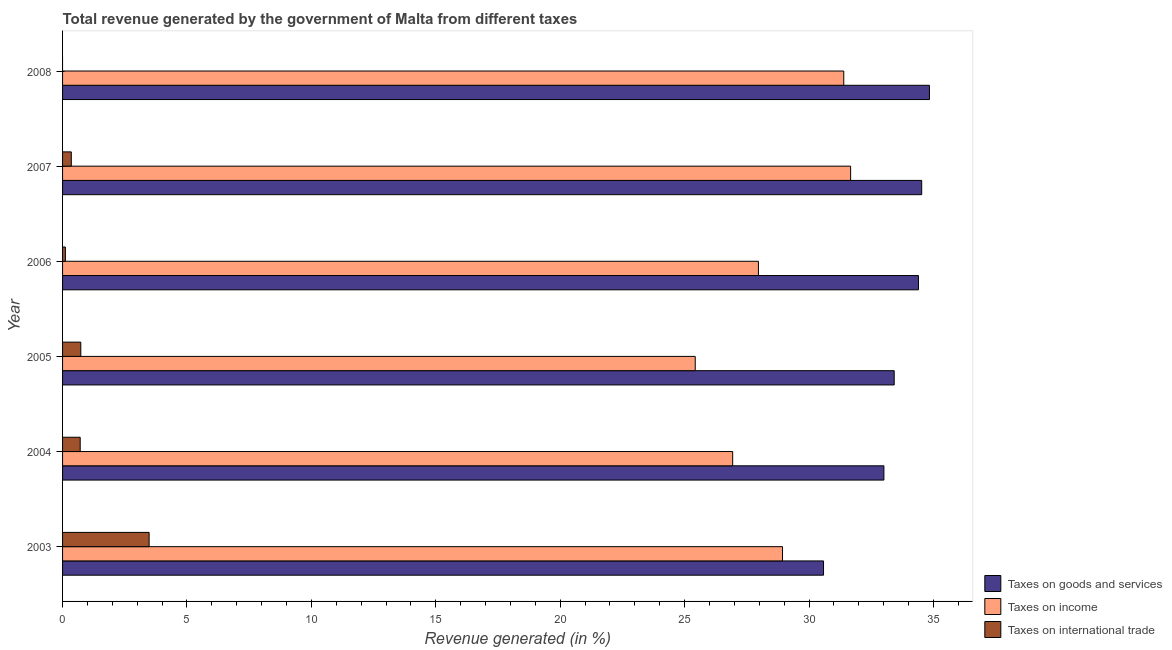Are the number of bars on each tick of the Y-axis equal?
Your answer should be very brief. No. What is the label of the 3rd group of bars from the top?
Give a very brief answer. 2006. In how many cases, is the number of bars for a given year not equal to the number of legend labels?
Keep it short and to the point. 1. What is the percentage of revenue generated by tax on international trade in 2004?
Make the answer very short. 0.71. Across all years, what is the maximum percentage of revenue generated by taxes on goods and services?
Your answer should be compact. 34.84. Across all years, what is the minimum percentage of revenue generated by taxes on income?
Your answer should be compact. 25.43. In which year was the percentage of revenue generated by taxes on goods and services maximum?
Make the answer very short. 2008. What is the total percentage of revenue generated by tax on international trade in the graph?
Provide a succinct answer. 5.38. What is the difference between the percentage of revenue generated by taxes on goods and services in 2003 and that in 2004?
Make the answer very short. -2.43. What is the difference between the percentage of revenue generated by taxes on goods and services in 2008 and the percentage of revenue generated by taxes on income in 2005?
Your answer should be compact. 9.41. What is the average percentage of revenue generated by tax on international trade per year?
Ensure brevity in your answer.  0.9. In the year 2007, what is the difference between the percentage of revenue generated by taxes on income and percentage of revenue generated by taxes on goods and services?
Your answer should be compact. -2.86. What is the ratio of the percentage of revenue generated by tax on international trade in 2004 to that in 2007?
Offer a very short reply. 2.02. Is the percentage of revenue generated by taxes on goods and services in 2004 less than that in 2006?
Your answer should be very brief. Yes. Is the difference between the percentage of revenue generated by taxes on income in 2004 and 2005 greater than the difference between the percentage of revenue generated by tax on international trade in 2004 and 2005?
Ensure brevity in your answer.  Yes. What is the difference between the highest and the second highest percentage of revenue generated by taxes on income?
Keep it short and to the point. 0.28. What is the difference between the highest and the lowest percentage of revenue generated by taxes on goods and services?
Ensure brevity in your answer.  4.26. In how many years, is the percentage of revenue generated by tax on international trade greater than the average percentage of revenue generated by tax on international trade taken over all years?
Your answer should be very brief. 1. Is the sum of the percentage of revenue generated by taxes on income in 2004 and 2006 greater than the maximum percentage of revenue generated by taxes on goods and services across all years?
Give a very brief answer. Yes. How many bars are there?
Your answer should be very brief. 17. Are all the bars in the graph horizontal?
Ensure brevity in your answer.  Yes. How many years are there in the graph?
Your answer should be compact. 6. What is the difference between two consecutive major ticks on the X-axis?
Ensure brevity in your answer.  5. Does the graph contain grids?
Your answer should be very brief. No. Where does the legend appear in the graph?
Offer a very short reply. Bottom right. How many legend labels are there?
Your answer should be very brief. 3. How are the legend labels stacked?
Offer a very short reply. Vertical. What is the title of the graph?
Provide a succinct answer. Total revenue generated by the government of Malta from different taxes. What is the label or title of the X-axis?
Offer a terse response. Revenue generated (in %). What is the Revenue generated (in %) of Taxes on goods and services in 2003?
Your answer should be very brief. 30.58. What is the Revenue generated (in %) in Taxes on income in 2003?
Provide a succinct answer. 28.93. What is the Revenue generated (in %) in Taxes on international trade in 2003?
Keep it short and to the point. 3.48. What is the Revenue generated (in %) in Taxes on goods and services in 2004?
Make the answer very short. 33.01. What is the Revenue generated (in %) in Taxes on income in 2004?
Make the answer very short. 26.93. What is the Revenue generated (in %) in Taxes on international trade in 2004?
Provide a succinct answer. 0.71. What is the Revenue generated (in %) of Taxes on goods and services in 2005?
Your answer should be very brief. 33.42. What is the Revenue generated (in %) in Taxes on income in 2005?
Your answer should be very brief. 25.43. What is the Revenue generated (in %) of Taxes on international trade in 2005?
Provide a short and direct response. 0.73. What is the Revenue generated (in %) of Taxes on goods and services in 2006?
Make the answer very short. 34.4. What is the Revenue generated (in %) of Taxes on income in 2006?
Keep it short and to the point. 27.97. What is the Revenue generated (in %) of Taxes on international trade in 2006?
Offer a very short reply. 0.11. What is the Revenue generated (in %) of Taxes on goods and services in 2007?
Provide a short and direct response. 34.53. What is the Revenue generated (in %) in Taxes on income in 2007?
Your answer should be compact. 31.67. What is the Revenue generated (in %) of Taxes on international trade in 2007?
Keep it short and to the point. 0.35. What is the Revenue generated (in %) in Taxes on goods and services in 2008?
Ensure brevity in your answer.  34.84. What is the Revenue generated (in %) of Taxes on income in 2008?
Your answer should be compact. 31.4. What is the Revenue generated (in %) of Taxes on international trade in 2008?
Give a very brief answer. 0. Across all years, what is the maximum Revenue generated (in %) of Taxes on goods and services?
Your answer should be very brief. 34.84. Across all years, what is the maximum Revenue generated (in %) in Taxes on income?
Ensure brevity in your answer.  31.67. Across all years, what is the maximum Revenue generated (in %) in Taxes on international trade?
Offer a very short reply. 3.48. Across all years, what is the minimum Revenue generated (in %) of Taxes on goods and services?
Make the answer very short. 30.58. Across all years, what is the minimum Revenue generated (in %) in Taxes on income?
Provide a succinct answer. 25.43. What is the total Revenue generated (in %) of Taxes on goods and services in the graph?
Keep it short and to the point. 200.78. What is the total Revenue generated (in %) in Taxes on income in the graph?
Provide a succinct answer. 172.32. What is the total Revenue generated (in %) in Taxes on international trade in the graph?
Offer a very short reply. 5.38. What is the difference between the Revenue generated (in %) in Taxes on goods and services in 2003 and that in 2004?
Provide a succinct answer. -2.43. What is the difference between the Revenue generated (in %) in Taxes on income in 2003 and that in 2004?
Keep it short and to the point. 2. What is the difference between the Revenue generated (in %) in Taxes on international trade in 2003 and that in 2004?
Provide a short and direct response. 2.77. What is the difference between the Revenue generated (in %) of Taxes on goods and services in 2003 and that in 2005?
Provide a succinct answer. -2.84. What is the difference between the Revenue generated (in %) in Taxes on income in 2003 and that in 2005?
Provide a short and direct response. 3.51. What is the difference between the Revenue generated (in %) of Taxes on international trade in 2003 and that in 2005?
Offer a very short reply. 2.75. What is the difference between the Revenue generated (in %) of Taxes on goods and services in 2003 and that in 2006?
Your response must be concise. -3.81. What is the difference between the Revenue generated (in %) of Taxes on income in 2003 and that in 2006?
Make the answer very short. 0.97. What is the difference between the Revenue generated (in %) of Taxes on international trade in 2003 and that in 2006?
Provide a succinct answer. 3.37. What is the difference between the Revenue generated (in %) in Taxes on goods and services in 2003 and that in 2007?
Provide a succinct answer. -3.95. What is the difference between the Revenue generated (in %) in Taxes on income in 2003 and that in 2007?
Give a very brief answer. -2.74. What is the difference between the Revenue generated (in %) in Taxes on international trade in 2003 and that in 2007?
Your answer should be compact. 3.13. What is the difference between the Revenue generated (in %) in Taxes on goods and services in 2003 and that in 2008?
Ensure brevity in your answer.  -4.26. What is the difference between the Revenue generated (in %) of Taxes on income in 2003 and that in 2008?
Ensure brevity in your answer.  -2.46. What is the difference between the Revenue generated (in %) in Taxes on goods and services in 2004 and that in 2005?
Offer a terse response. -0.41. What is the difference between the Revenue generated (in %) in Taxes on income in 2004 and that in 2005?
Ensure brevity in your answer.  1.5. What is the difference between the Revenue generated (in %) of Taxes on international trade in 2004 and that in 2005?
Make the answer very short. -0.02. What is the difference between the Revenue generated (in %) in Taxes on goods and services in 2004 and that in 2006?
Give a very brief answer. -1.39. What is the difference between the Revenue generated (in %) in Taxes on income in 2004 and that in 2006?
Ensure brevity in your answer.  -1.03. What is the difference between the Revenue generated (in %) of Taxes on international trade in 2004 and that in 2006?
Provide a succinct answer. 0.59. What is the difference between the Revenue generated (in %) of Taxes on goods and services in 2004 and that in 2007?
Your answer should be very brief. -1.52. What is the difference between the Revenue generated (in %) of Taxes on income in 2004 and that in 2007?
Keep it short and to the point. -4.74. What is the difference between the Revenue generated (in %) of Taxes on international trade in 2004 and that in 2007?
Your answer should be very brief. 0.36. What is the difference between the Revenue generated (in %) in Taxes on goods and services in 2004 and that in 2008?
Your answer should be compact. -1.83. What is the difference between the Revenue generated (in %) in Taxes on income in 2004 and that in 2008?
Your response must be concise. -4.46. What is the difference between the Revenue generated (in %) in Taxes on goods and services in 2005 and that in 2006?
Provide a succinct answer. -0.97. What is the difference between the Revenue generated (in %) of Taxes on income in 2005 and that in 2006?
Keep it short and to the point. -2.54. What is the difference between the Revenue generated (in %) of Taxes on international trade in 2005 and that in 2006?
Make the answer very short. 0.62. What is the difference between the Revenue generated (in %) of Taxes on goods and services in 2005 and that in 2007?
Provide a short and direct response. -1.11. What is the difference between the Revenue generated (in %) in Taxes on income in 2005 and that in 2007?
Your answer should be very brief. -6.24. What is the difference between the Revenue generated (in %) in Taxes on international trade in 2005 and that in 2007?
Keep it short and to the point. 0.38. What is the difference between the Revenue generated (in %) of Taxes on goods and services in 2005 and that in 2008?
Your answer should be very brief. -1.42. What is the difference between the Revenue generated (in %) of Taxes on income in 2005 and that in 2008?
Give a very brief answer. -5.97. What is the difference between the Revenue generated (in %) of Taxes on goods and services in 2006 and that in 2007?
Give a very brief answer. -0.13. What is the difference between the Revenue generated (in %) of Taxes on income in 2006 and that in 2007?
Keep it short and to the point. -3.71. What is the difference between the Revenue generated (in %) of Taxes on international trade in 2006 and that in 2007?
Offer a terse response. -0.24. What is the difference between the Revenue generated (in %) of Taxes on goods and services in 2006 and that in 2008?
Ensure brevity in your answer.  -0.44. What is the difference between the Revenue generated (in %) of Taxes on income in 2006 and that in 2008?
Your answer should be very brief. -3.43. What is the difference between the Revenue generated (in %) in Taxes on goods and services in 2007 and that in 2008?
Offer a very short reply. -0.31. What is the difference between the Revenue generated (in %) in Taxes on income in 2007 and that in 2008?
Keep it short and to the point. 0.28. What is the difference between the Revenue generated (in %) of Taxes on goods and services in 2003 and the Revenue generated (in %) of Taxes on income in 2004?
Provide a short and direct response. 3.65. What is the difference between the Revenue generated (in %) in Taxes on goods and services in 2003 and the Revenue generated (in %) in Taxes on international trade in 2004?
Your answer should be compact. 29.87. What is the difference between the Revenue generated (in %) in Taxes on income in 2003 and the Revenue generated (in %) in Taxes on international trade in 2004?
Provide a succinct answer. 28.23. What is the difference between the Revenue generated (in %) of Taxes on goods and services in 2003 and the Revenue generated (in %) of Taxes on income in 2005?
Offer a terse response. 5.16. What is the difference between the Revenue generated (in %) of Taxes on goods and services in 2003 and the Revenue generated (in %) of Taxes on international trade in 2005?
Your response must be concise. 29.85. What is the difference between the Revenue generated (in %) of Taxes on income in 2003 and the Revenue generated (in %) of Taxes on international trade in 2005?
Provide a short and direct response. 28.2. What is the difference between the Revenue generated (in %) of Taxes on goods and services in 2003 and the Revenue generated (in %) of Taxes on income in 2006?
Provide a succinct answer. 2.62. What is the difference between the Revenue generated (in %) of Taxes on goods and services in 2003 and the Revenue generated (in %) of Taxes on international trade in 2006?
Your answer should be compact. 30.47. What is the difference between the Revenue generated (in %) of Taxes on income in 2003 and the Revenue generated (in %) of Taxes on international trade in 2006?
Give a very brief answer. 28.82. What is the difference between the Revenue generated (in %) in Taxes on goods and services in 2003 and the Revenue generated (in %) in Taxes on income in 2007?
Ensure brevity in your answer.  -1.09. What is the difference between the Revenue generated (in %) of Taxes on goods and services in 2003 and the Revenue generated (in %) of Taxes on international trade in 2007?
Make the answer very short. 30.23. What is the difference between the Revenue generated (in %) in Taxes on income in 2003 and the Revenue generated (in %) in Taxes on international trade in 2007?
Offer a very short reply. 28.58. What is the difference between the Revenue generated (in %) of Taxes on goods and services in 2003 and the Revenue generated (in %) of Taxes on income in 2008?
Provide a succinct answer. -0.81. What is the difference between the Revenue generated (in %) in Taxes on goods and services in 2004 and the Revenue generated (in %) in Taxes on income in 2005?
Make the answer very short. 7.58. What is the difference between the Revenue generated (in %) in Taxes on goods and services in 2004 and the Revenue generated (in %) in Taxes on international trade in 2005?
Offer a very short reply. 32.28. What is the difference between the Revenue generated (in %) in Taxes on income in 2004 and the Revenue generated (in %) in Taxes on international trade in 2005?
Provide a short and direct response. 26.2. What is the difference between the Revenue generated (in %) in Taxes on goods and services in 2004 and the Revenue generated (in %) in Taxes on income in 2006?
Give a very brief answer. 5.04. What is the difference between the Revenue generated (in %) of Taxes on goods and services in 2004 and the Revenue generated (in %) of Taxes on international trade in 2006?
Provide a short and direct response. 32.9. What is the difference between the Revenue generated (in %) of Taxes on income in 2004 and the Revenue generated (in %) of Taxes on international trade in 2006?
Make the answer very short. 26.82. What is the difference between the Revenue generated (in %) in Taxes on goods and services in 2004 and the Revenue generated (in %) in Taxes on income in 2007?
Offer a terse response. 1.34. What is the difference between the Revenue generated (in %) of Taxes on goods and services in 2004 and the Revenue generated (in %) of Taxes on international trade in 2007?
Give a very brief answer. 32.66. What is the difference between the Revenue generated (in %) of Taxes on income in 2004 and the Revenue generated (in %) of Taxes on international trade in 2007?
Provide a short and direct response. 26.58. What is the difference between the Revenue generated (in %) of Taxes on goods and services in 2004 and the Revenue generated (in %) of Taxes on income in 2008?
Give a very brief answer. 1.61. What is the difference between the Revenue generated (in %) in Taxes on goods and services in 2005 and the Revenue generated (in %) in Taxes on income in 2006?
Your answer should be very brief. 5.46. What is the difference between the Revenue generated (in %) of Taxes on goods and services in 2005 and the Revenue generated (in %) of Taxes on international trade in 2006?
Offer a terse response. 33.31. What is the difference between the Revenue generated (in %) of Taxes on income in 2005 and the Revenue generated (in %) of Taxes on international trade in 2006?
Your response must be concise. 25.31. What is the difference between the Revenue generated (in %) in Taxes on goods and services in 2005 and the Revenue generated (in %) in Taxes on income in 2007?
Ensure brevity in your answer.  1.75. What is the difference between the Revenue generated (in %) of Taxes on goods and services in 2005 and the Revenue generated (in %) of Taxes on international trade in 2007?
Your answer should be very brief. 33.07. What is the difference between the Revenue generated (in %) in Taxes on income in 2005 and the Revenue generated (in %) in Taxes on international trade in 2007?
Your response must be concise. 25.08. What is the difference between the Revenue generated (in %) of Taxes on goods and services in 2005 and the Revenue generated (in %) of Taxes on income in 2008?
Make the answer very short. 2.03. What is the difference between the Revenue generated (in %) of Taxes on goods and services in 2006 and the Revenue generated (in %) of Taxes on income in 2007?
Provide a succinct answer. 2.73. What is the difference between the Revenue generated (in %) in Taxes on goods and services in 2006 and the Revenue generated (in %) in Taxes on international trade in 2007?
Offer a terse response. 34.05. What is the difference between the Revenue generated (in %) of Taxes on income in 2006 and the Revenue generated (in %) of Taxes on international trade in 2007?
Your answer should be compact. 27.61. What is the difference between the Revenue generated (in %) in Taxes on goods and services in 2006 and the Revenue generated (in %) in Taxes on income in 2008?
Give a very brief answer. 3. What is the difference between the Revenue generated (in %) of Taxes on goods and services in 2007 and the Revenue generated (in %) of Taxes on income in 2008?
Provide a short and direct response. 3.13. What is the average Revenue generated (in %) of Taxes on goods and services per year?
Offer a very short reply. 33.46. What is the average Revenue generated (in %) of Taxes on income per year?
Provide a succinct answer. 28.72. What is the average Revenue generated (in %) in Taxes on international trade per year?
Offer a very short reply. 0.9. In the year 2003, what is the difference between the Revenue generated (in %) of Taxes on goods and services and Revenue generated (in %) of Taxes on income?
Make the answer very short. 1.65. In the year 2003, what is the difference between the Revenue generated (in %) in Taxes on goods and services and Revenue generated (in %) in Taxes on international trade?
Ensure brevity in your answer.  27.1. In the year 2003, what is the difference between the Revenue generated (in %) of Taxes on income and Revenue generated (in %) of Taxes on international trade?
Make the answer very short. 25.45. In the year 2004, what is the difference between the Revenue generated (in %) in Taxes on goods and services and Revenue generated (in %) in Taxes on income?
Provide a succinct answer. 6.08. In the year 2004, what is the difference between the Revenue generated (in %) of Taxes on goods and services and Revenue generated (in %) of Taxes on international trade?
Ensure brevity in your answer.  32.3. In the year 2004, what is the difference between the Revenue generated (in %) in Taxes on income and Revenue generated (in %) in Taxes on international trade?
Offer a very short reply. 26.22. In the year 2005, what is the difference between the Revenue generated (in %) of Taxes on goods and services and Revenue generated (in %) of Taxes on income?
Give a very brief answer. 8. In the year 2005, what is the difference between the Revenue generated (in %) of Taxes on goods and services and Revenue generated (in %) of Taxes on international trade?
Your response must be concise. 32.69. In the year 2005, what is the difference between the Revenue generated (in %) of Taxes on income and Revenue generated (in %) of Taxes on international trade?
Keep it short and to the point. 24.69. In the year 2006, what is the difference between the Revenue generated (in %) in Taxes on goods and services and Revenue generated (in %) in Taxes on income?
Your answer should be very brief. 6.43. In the year 2006, what is the difference between the Revenue generated (in %) in Taxes on goods and services and Revenue generated (in %) in Taxes on international trade?
Make the answer very short. 34.28. In the year 2006, what is the difference between the Revenue generated (in %) in Taxes on income and Revenue generated (in %) in Taxes on international trade?
Your answer should be compact. 27.85. In the year 2007, what is the difference between the Revenue generated (in %) in Taxes on goods and services and Revenue generated (in %) in Taxes on income?
Provide a succinct answer. 2.86. In the year 2007, what is the difference between the Revenue generated (in %) of Taxes on goods and services and Revenue generated (in %) of Taxes on international trade?
Provide a short and direct response. 34.18. In the year 2007, what is the difference between the Revenue generated (in %) of Taxes on income and Revenue generated (in %) of Taxes on international trade?
Offer a very short reply. 31.32. In the year 2008, what is the difference between the Revenue generated (in %) of Taxes on goods and services and Revenue generated (in %) of Taxes on income?
Your answer should be compact. 3.44. What is the ratio of the Revenue generated (in %) of Taxes on goods and services in 2003 to that in 2004?
Keep it short and to the point. 0.93. What is the ratio of the Revenue generated (in %) of Taxes on income in 2003 to that in 2004?
Ensure brevity in your answer.  1.07. What is the ratio of the Revenue generated (in %) in Taxes on international trade in 2003 to that in 2004?
Offer a very short reply. 4.91. What is the ratio of the Revenue generated (in %) of Taxes on goods and services in 2003 to that in 2005?
Offer a terse response. 0.92. What is the ratio of the Revenue generated (in %) in Taxes on income in 2003 to that in 2005?
Your answer should be compact. 1.14. What is the ratio of the Revenue generated (in %) in Taxes on international trade in 2003 to that in 2005?
Provide a succinct answer. 4.75. What is the ratio of the Revenue generated (in %) of Taxes on goods and services in 2003 to that in 2006?
Provide a short and direct response. 0.89. What is the ratio of the Revenue generated (in %) of Taxes on income in 2003 to that in 2006?
Ensure brevity in your answer.  1.03. What is the ratio of the Revenue generated (in %) in Taxes on international trade in 2003 to that in 2006?
Keep it short and to the point. 30.68. What is the ratio of the Revenue generated (in %) in Taxes on goods and services in 2003 to that in 2007?
Offer a very short reply. 0.89. What is the ratio of the Revenue generated (in %) of Taxes on income in 2003 to that in 2007?
Give a very brief answer. 0.91. What is the ratio of the Revenue generated (in %) of Taxes on international trade in 2003 to that in 2007?
Make the answer very short. 9.92. What is the ratio of the Revenue generated (in %) of Taxes on goods and services in 2003 to that in 2008?
Make the answer very short. 0.88. What is the ratio of the Revenue generated (in %) in Taxes on income in 2003 to that in 2008?
Give a very brief answer. 0.92. What is the ratio of the Revenue generated (in %) in Taxes on goods and services in 2004 to that in 2005?
Provide a succinct answer. 0.99. What is the ratio of the Revenue generated (in %) in Taxes on income in 2004 to that in 2005?
Make the answer very short. 1.06. What is the ratio of the Revenue generated (in %) in Taxes on international trade in 2004 to that in 2005?
Give a very brief answer. 0.97. What is the ratio of the Revenue generated (in %) in Taxes on goods and services in 2004 to that in 2006?
Offer a very short reply. 0.96. What is the ratio of the Revenue generated (in %) in Taxes on income in 2004 to that in 2006?
Offer a terse response. 0.96. What is the ratio of the Revenue generated (in %) of Taxes on international trade in 2004 to that in 2006?
Offer a very short reply. 6.25. What is the ratio of the Revenue generated (in %) in Taxes on goods and services in 2004 to that in 2007?
Keep it short and to the point. 0.96. What is the ratio of the Revenue generated (in %) of Taxes on income in 2004 to that in 2007?
Your answer should be compact. 0.85. What is the ratio of the Revenue generated (in %) of Taxes on international trade in 2004 to that in 2007?
Your answer should be very brief. 2.02. What is the ratio of the Revenue generated (in %) in Taxes on goods and services in 2004 to that in 2008?
Make the answer very short. 0.95. What is the ratio of the Revenue generated (in %) of Taxes on income in 2004 to that in 2008?
Offer a terse response. 0.86. What is the ratio of the Revenue generated (in %) of Taxes on goods and services in 2005 to that in 2006?
Provide a short and direct response. 0.97. What is the ratio of the Revenue generated (in %) in Taxes on income in 2005 to that in 2006?
Keep it short and to the point. 0.91. What is the ratio of the Revenue generated (in %) in Taxes on international trade in 2005 to that in 2006?
Offer a terse response. 6.46. What is the ratio of the Revenue generated (in %) in Taxes on goods and services in 2005 to that in 2007?
Your answer should be very brief. 0.97. What is the ratio of the Revenue generated (in %) of Taxes on income in 2005 to that in 2007?
Give a very brief answer. 0.8. What is the ratio of the Revenue generated (in %) of Taxes on international trade in 2005 to that in 2007?
Provide a succinct answer. 2.09. What is the ratio of the Revenue generated (in %) in Taxes on goods and services in 2005 to that in 2008?
Your answer should be compact. 0.96. What is the ratio of the Revenue generated (in %) in Taxes on income in 2005 to that in 2008?
Offer a very short reply. 0.81. What is the ratio of the Revenue generated (in %) in Taxes on goods and services in 2006 to that in 2007?
Ensure brevity in your answer.  1. What is the ratio of the Revenue generated (in %) of Taxes on income in 2006 to that in 2007?
Keep it short and to the point. 0.88. What is the ratio of the Revenue generated (in %) of Taxes on international trade in 2006 to that in 2007?
Provide a short and direct response. 0.32. What is the ratio of the Revenue generated (in %) of Taxes on goods and services in 2006 to that in 2008?
Your answer should be compact. 0.99. What is the ratio of the Revenue generated (in %) of Taxes on income in 2006 to that in 2008?
Give a very brief answer. 0.89. What is the ratio of the Revenue generated (in %) in Taxes on goods and services in 2007 to that in 2008?
Ensure brevity in your answer.  0.99. What is the ratio of the Revenue generated (in %) in Taxes on income in 2007 to that in 2008?
Provide a short and direct response. 1.01. What is the difference between the highest and the second highest Revenue generated (in %) of Taxes on goods and services?
Provide a succinct answer. 0.31. What is the difference between the highest and the second highest Revenue generated (in %) in Taxes on income?
Make the answer very short. 0.28. What is the difference between the highest and the second highest Revenue generated (in %) of Taxes on international trade?
Ensure brevity in your answer.  2.75. What is the difference between the highest and the lowest Revenue generated (in %) of Taxes on goods and services?
Ensure brevity in your answer.  4.26. What is the difference between the highest and the lowest Revenue generated (in %) in Taxes on income?
Your answer should be compact. 6.24. What is the difference between the highest and the lowest Revenue generated (in %) in Taxes on international trade?
Provide a short and direct response. 3.48. 